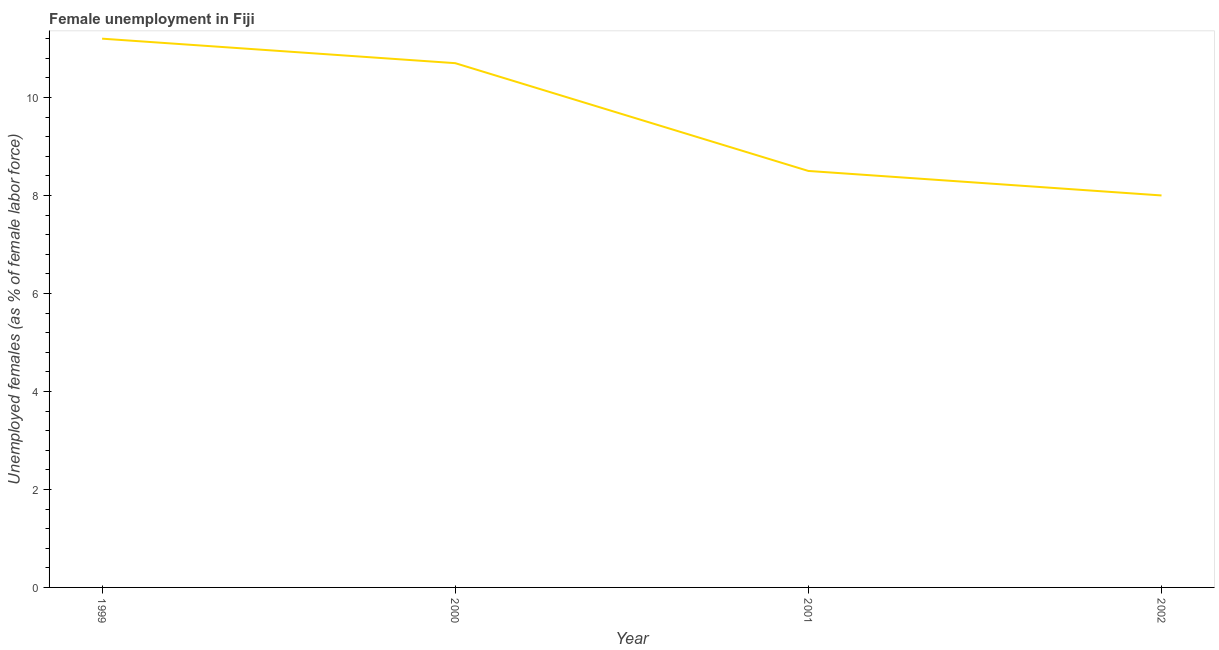What is the unemployed females population in 2000?
Provide a short and direct response. 10.7. Across all years, what is the maximum unemployed females population?
Offer a very short reply. 11.2. Across all years, what is the minimum unemployed females population?
Offer a very short reply. 8. In which year was the unemployed females population maximum?
Offer a very short reply. 1999. In which year was the unemployed females population minimum?
Offer a very short reply. 2002. What is the sum of the unemployed females population?
Provide a succinct answer. 38.4. What is the average unemployed females population per year?
Your response must be concise. 9.6. What is the median unemployed females population?
Your response must be concise. 9.6. Do a majority of the years between 1999 and 2002 (inclusive) have unemployed females population greater than 8.8 %?
Offer a terse response. No. What is the ratio of the unemployed females population in 1999 to that in 2000?
Make the answer very short. 1.05. Is the unemployed females population in 1999 less than that in 2002?
Provide a succinct answer. No. What is the difference between the highest and the second highest unemployed females population?
Your response must be concise. 0.5. Is the sum of the unemployed females population in 2000 and 2001 greater than the maximum unemployed females population across all years?
Make the answer very short. Yes. What is the difference between the highest and the lowest unemployed females population?
Your answer should be very brief. 3.2. In how many years, is the unemployed females population greater than the average unemployed females population taken over all years?
Offer a terse response. 2. Does the unemployed females population monotonically increase over the years?
Keep it short and to the point. No. How many lines are there?
Provide a succinct answer. 1. What is the title of the graph?
Offer a terse response. Female unemployment in Fiji. What is the label or title of the Y-axis?
Your response must be concise. Unemployed females (as % of female labor force). What is the Unemployed females (as % of female labor force) of 1999?
Provide a short and direct response. 11.2. What is the Unemployed females (as % of female labor force) of 2000?
Make the answer very short. 10.7. What is the difference between the Unemployed females (as % of female labor force) in 1999 and 2001?
Provide a succinct answer. 2.7. What is the difference between the Unemployed females (as % of female labor force) in 2001 and 2002?
Keep it short and to the point. 0.5. What is the ratio of the Unemployed females (as % of female labor force) in 1999 to that in 2000?
Provide a short and direct response. 1.05. What is the ratio of the Unemployed females (as % of female labor force) in 1999 to that in 2001?
Provide a short and direct response. 1.32. What is the ratio of the Unemployed females (as % of female labor force) in 1999 to that in 2002?
Your answer should be very brief. 1.4. What is the ratio of the Unemployed females (as % of female labor force) in 2000 to that in 2001?
Your answer should be compact. 1.26. What is the ratio of the Unemployed females (as % of female labor force) in 2000 to that in 2002?
Keep it short and to the point. 1.34. What is the ratio of the Unemployed females (as % of female labor force) in 2001 to that in 2002?
Provide a succinct answer. 1.06. 